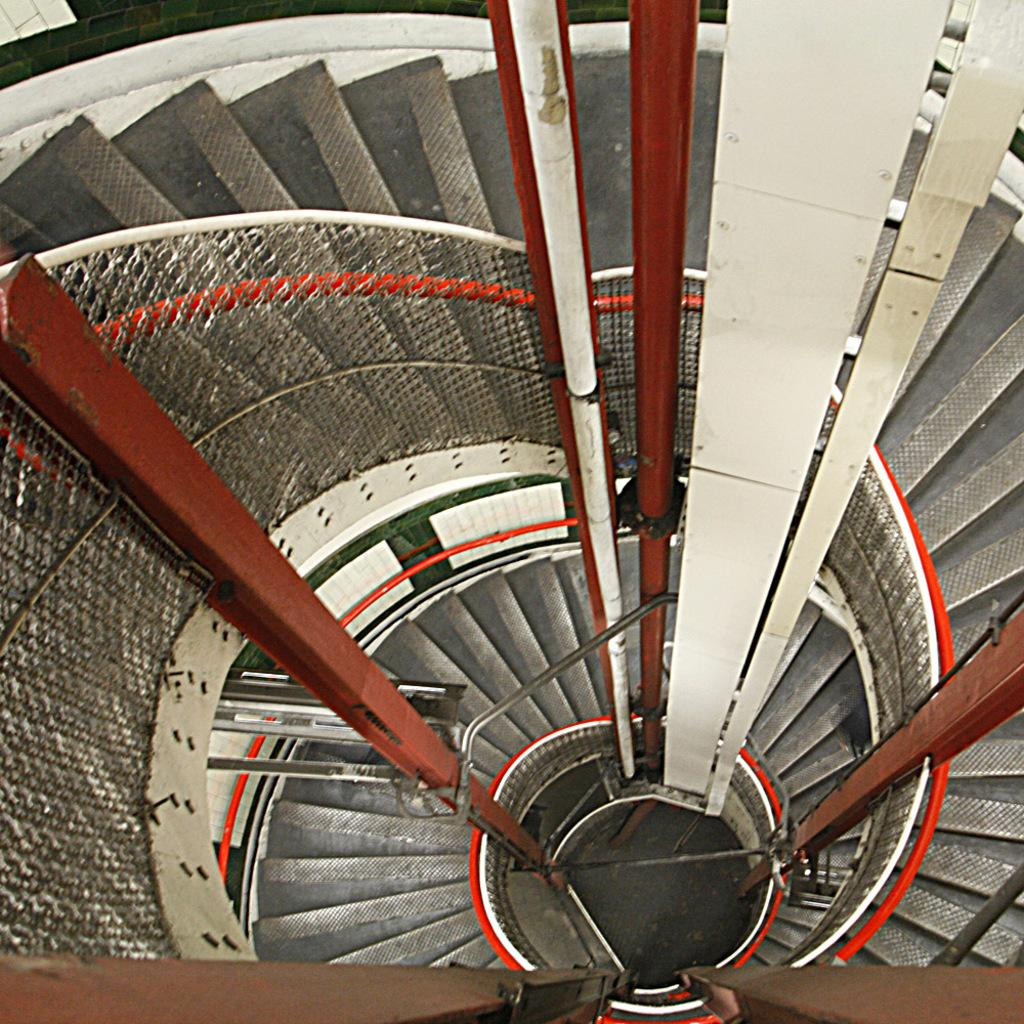What type of structure is present in the image? There are stairs in the image. What feature is present alongside the stairs? There is a railing in the image. What else can be seen in the image besides the stairs and railing? There are pipes in the image. Where is the sister located in the image? There is no sister present in the image. What type of vegetable is being used to create the form in the image? There is no vegetable or form present in the image. 